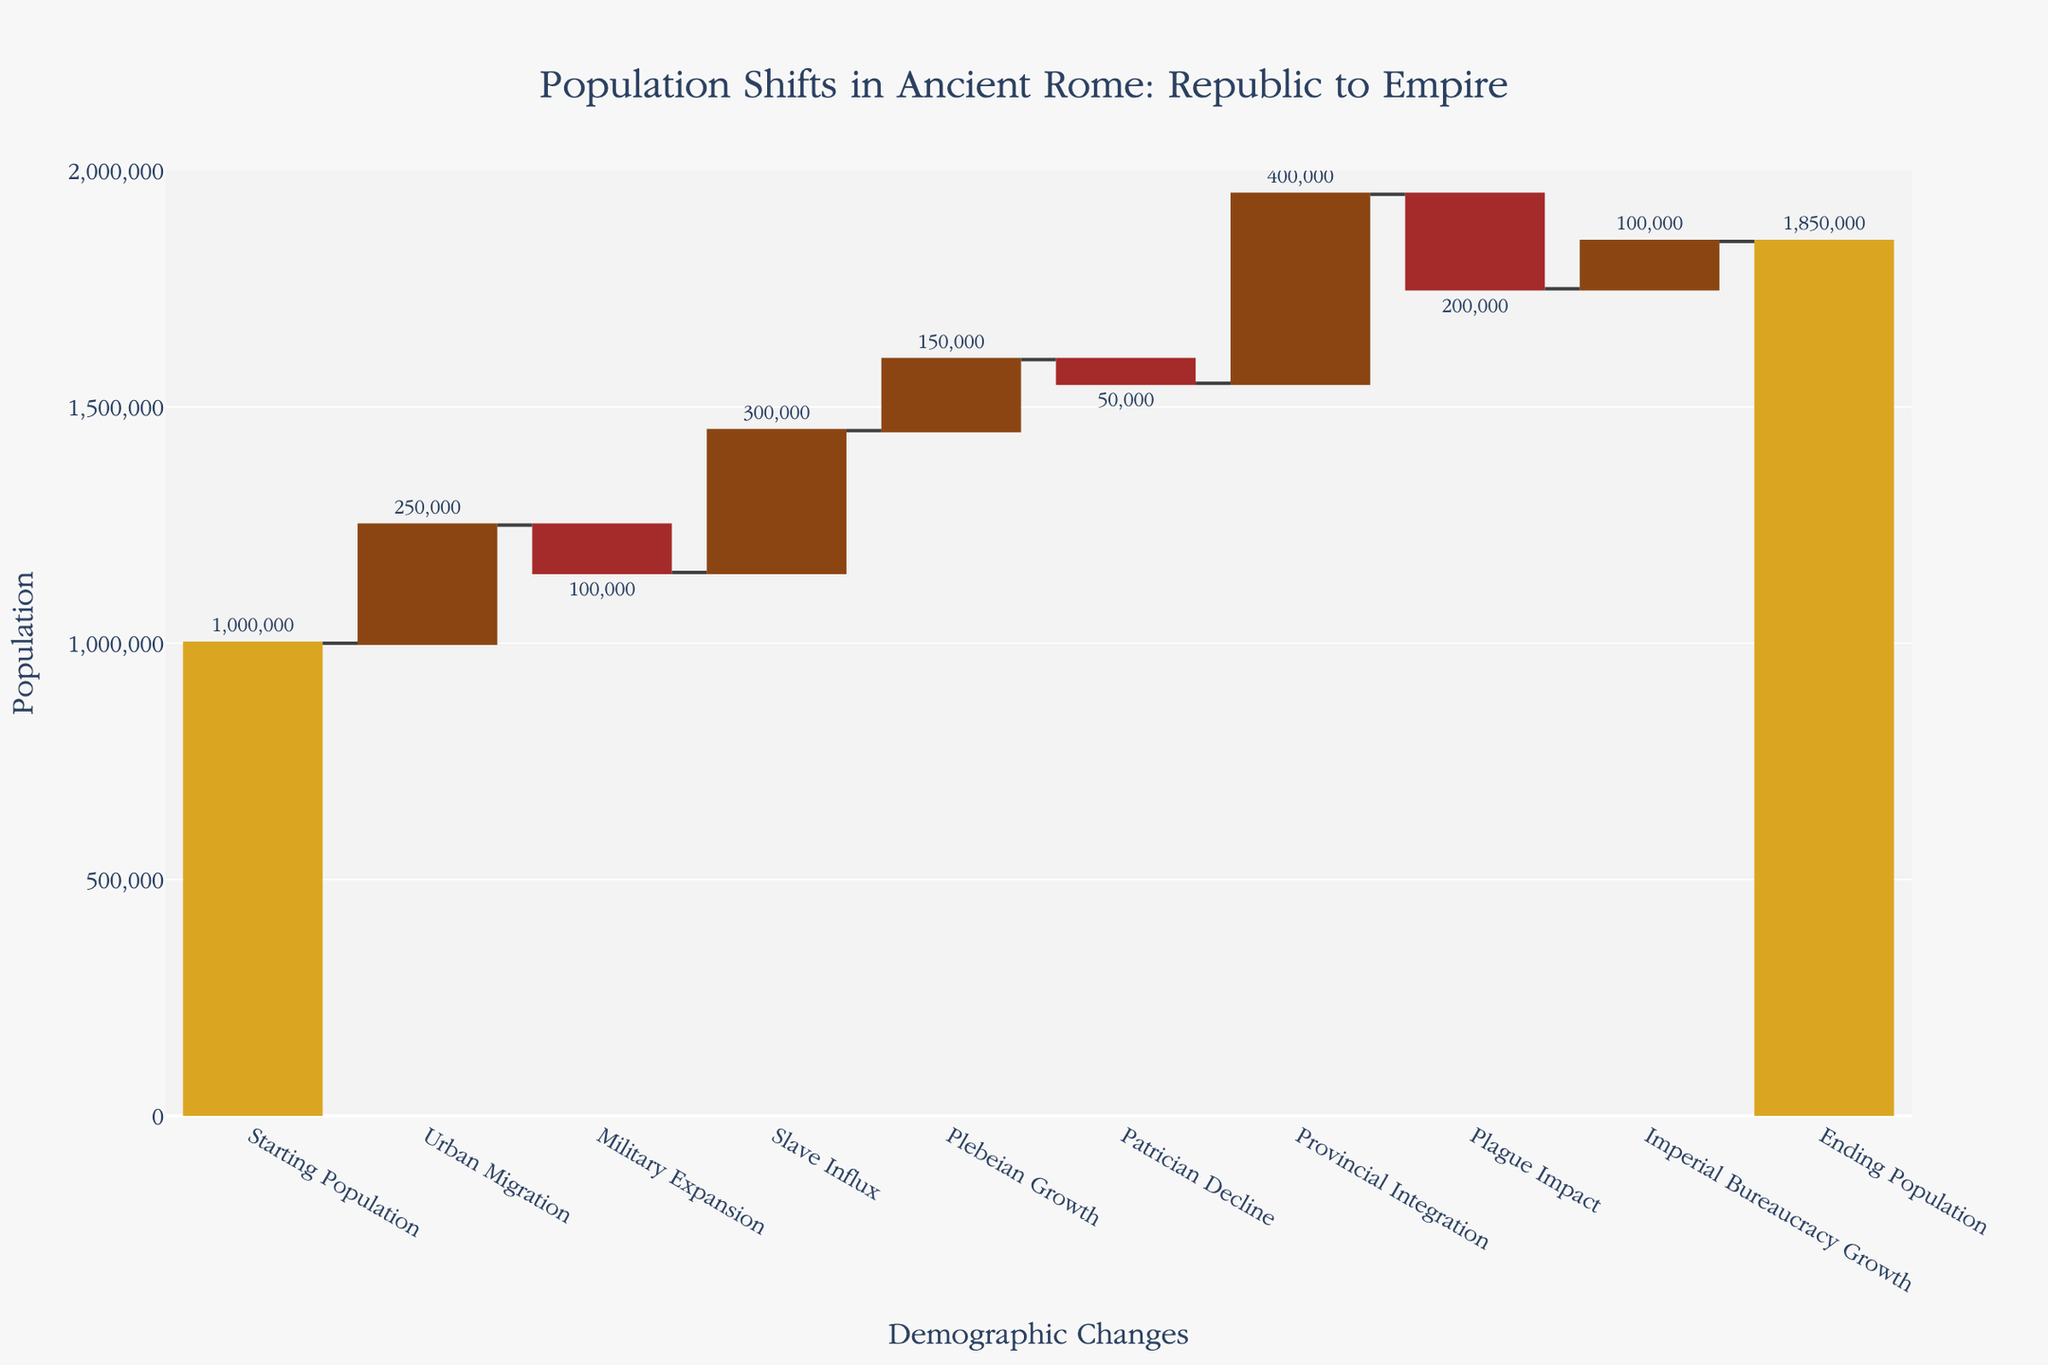What is the title of the chart? The title of the chart is located at the top of the figure, and it provides a summary of what the chart represents. In this case, it is "Population Shifts in Ancient Rome: Republic to Empire."
Answer: Population Shifts in Ancient Rome: Republic to Empire How many categories of demographic changes are represented in the chart? The figure shows nine categories of demographic changes. These categories are listed along the x-axis and include things like Urban Migration, Military Expansion, and Plague Impact.
Answer: Nine Which demographic change had the largest positive impact on the population? Look at the category bars on the chart to see which is the tallest in the upward direction. The Slave Influx bar has the highest value, indicating the largest positive impact.
Answer: Slave Influx What was the population increase due to Urban Migration? The Urban Migration bar is labeled with the value indicating the population increase due to this change. It shows an increase of 250,000.
Answer: 250,000 Which category had the most significant negative impact on the population? To determine the most significant negative impact, find the bar that extends the furthest downward. The Plague Impact category shows the largest drop, indicating a decrease of 200,000.
Answer: Plague Impact What is the sum of the population changes due to Urban Migration and Slave Influx? Add the population increases from Urban Migration (250,000) and Slave Influx (300,000). This gives a sum of 250,000 + 300,000 = 550,000.
Answer: 550,000 How does the population decrease from Military Expansion compare to Patrician Decline? Compare the values of the downward bars for Military Expansion (-100,000) and Patrician Decline (-50,000). Military Expansion has a larger negative value.
Answer: Military Expansion has a larger decrease What was the net population change resulting from the Plebeian Growth and Patrician Decline combined? Calculate the difference by adding the population increase from Plebeian Growth (150,000) and the population decrease from Patrician Decline (-50,000). This gives 150,000 - 50,000 = 100,000.
Answer: 100,000 By how much did the Provincial Integration affect the population compared to the Plague Impact? The Provincial Integration added 400,000 to the population, while the Plague Impact reduced it by 200,000. The net effect is 400,000 - 200,000 = 200,000.
Answer: 200,000 What was the final population at the end of the chart? The Ending Population category, displayed at the end of the chart, indicates the final population. It shows 1,850,000.
Answer: 1,850,000 